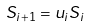Convert formula to latex. <formula><loc_0><loc_0><loc_500><loc_500>S _ { i + 1 } = u _ { i } S _ { i }</formula> 